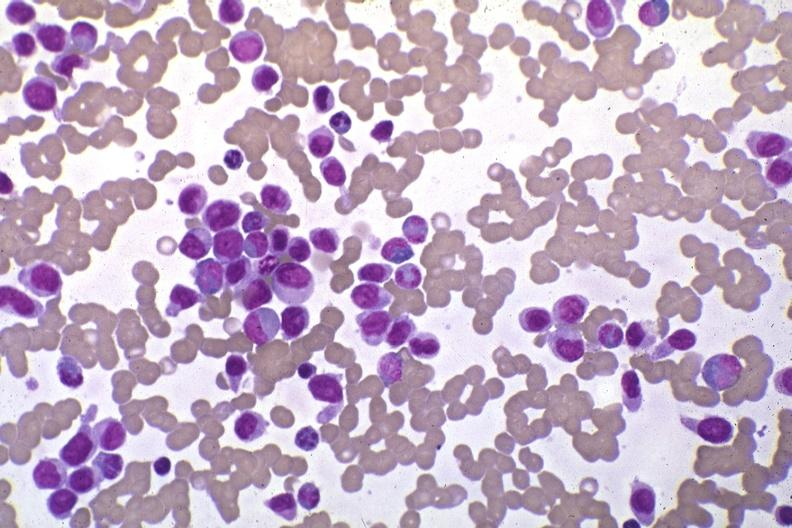what does this image show?
Answer the question using a single word or phrase. Wrights stain pleomorphic leukemic cells in peripheral blood prior to therapy 